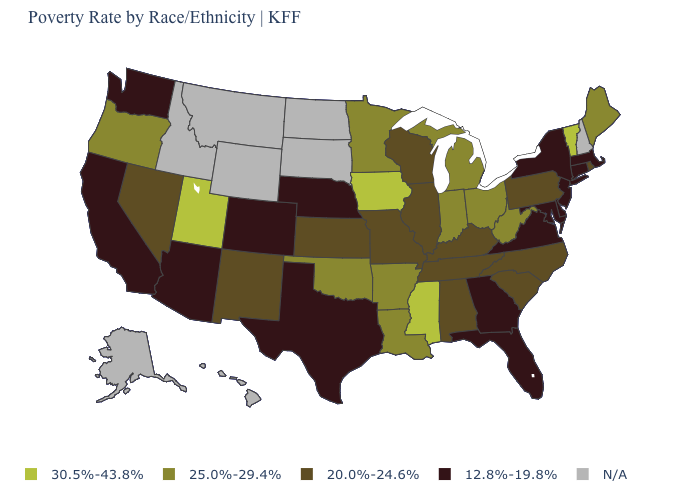Among the states that border West Virginia , which have the highest value?
Give a very brief answer. Ohio. Among the states that border Arkansas , which have the highest value?
Answer briefly. Mississippi. What is the lowest value in the USA?
Short answer required. 12.8%-19.8%. What is the value of North Carolina?
Short answer required. 20.0%-24.6%. What is the value of Minnesota?
Answer briefly. 25.0%-29.4%. What is the value of Minnesota?
Quick response, please. 25.0%-29.4%. Which states have the highest value in the USA?
Be succinct. Iowa, Mississippi, Utah, Vermont. Among the states that border Tennessee , which have the highest value?
Short answer required. Mississippi. Name the states that have a value in the range 25.0%-29.4%?
Quick response, please. Arkansas, Indiana, Louisiana, Maine, Michigan, Minnesota, Ohio, Oklahoma, Oregon, West Virginia. Which states have the lowest value in the South?
Concise answer only. Delaware, Florida, Georgia, Maryland, Texas, Virginia. Name the states that have a value in the range 20.0%-24.6%?
Quick response, please. Alabama, Illinois, Kansas, Kentucky, Missouri, Nevada, New Mexico, North Carolina, Pennsylvania, Rhode Island, South Carolina, Tennessee, Wisconsin. Does Wisconsin have the highest value in the MidWest?
Answer briefly. No. Name the states that have a value in the range 20.0%-24.6%?
Be succinct. Alabama, Illinois, Kansas, Kentucky, Missouri, Nevada, New Mexico, North Carolina, Pennsylvania, Rhode Island, South Carolina, Tennessee, Wisconsin. 